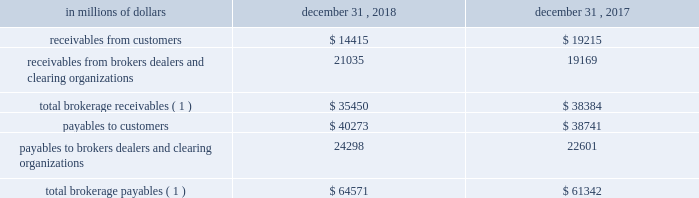12 .
Brokerage receivables and brokerage payables the company has receivables and payables for financial instruments sold to and purchased from brokers , dealers and customers , which arise in the ordinary course of business .
Citi is exposed to risk of loss from the inability of brokers , dealers or customers to pay for purchases or to deliver the financial instruments sold , in which case citi would have to sell or purchase the financial instruments at prevailing market prices .
Credit risk is reduced to the extent that an exchange or clearing organization acts as a counterparty to the transaction and replaces the broker , dealer or customer in question .
Citi seeks to protect itself from the risks associated with customer activities by requiring customers to maintain margin collateral in compliance with regulatory and internal guidelines .
Margin levels are monitored daily , and customers deposit additional collateral as required .
Where customers cannot meet collateral requirements , citi may liquidate sufficient underlying financial instruments to bring the customer into compliance with the required margin level .
Exposure to credit risk is impacted by market volatility , which may impair the ability of clients to satisfy their obligations to citi .
Credit limits are established and closely monitored for customers and for brokers and dealers engaged in forwards , futures and other transactions deemed to be credit sensitive .
Brokerage receivables and brokerage payables consisted of the following: .
Total brokerage payables ( 1 ) $ 64571 $ 61342 ( 1 ) includes brokerage receivables and payables recorded by citi broker-dealer entities that are accounted for in accordance with the aicpa accounting guide for brokers and dealers in securities as codified in asc 940-320. .
In 2018 what was the ratio of the total brokerage payables to total brokerage receivables? 
Rationale: in 2018 there was $ 1.8 total brokerage payables for each total brokerage receivable
Computations: (64571 / 35450)
Answer: 1.82147. 